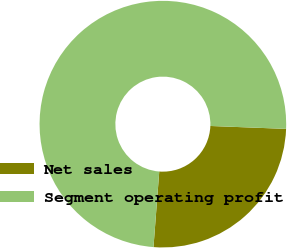Convert chart. <chart><loc_0><loc_0><loc_500><loc_500><pie_chart><fcel>Net sales<fcel>Segment operating profit<nl><fcel>25.6%<fcel>74.4%<nl></chart> 